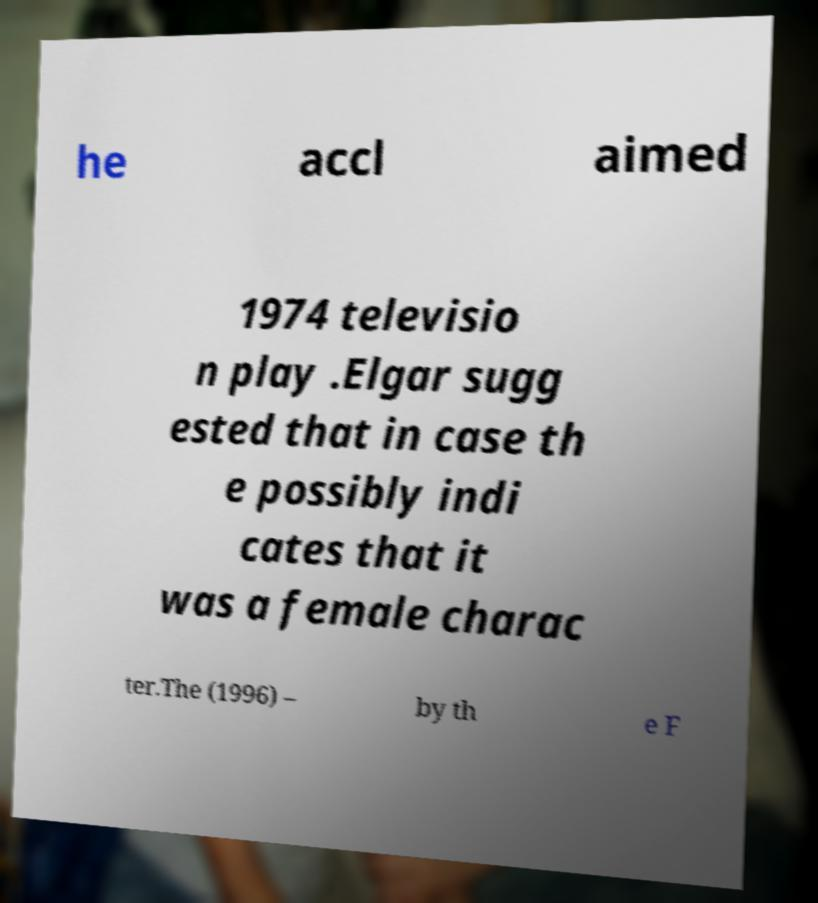What messages or text are displayed in this image? I need them in a readable, typed format. he accl aimed 1974 televisio n play .Elgar sugg ested that in case th e possibly indi cates that it was a female charac ter.The (1996) – by th e F 